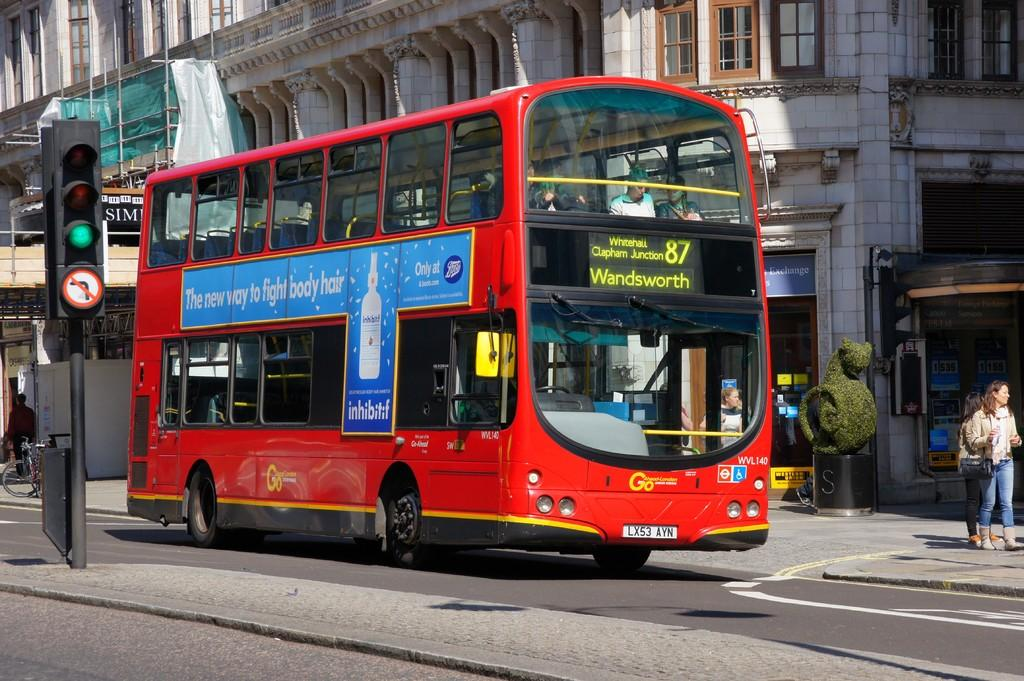<image>
Create a compact narrative representing the image presented. A red bus is on the number 87 route, heading to Wandsworth. 